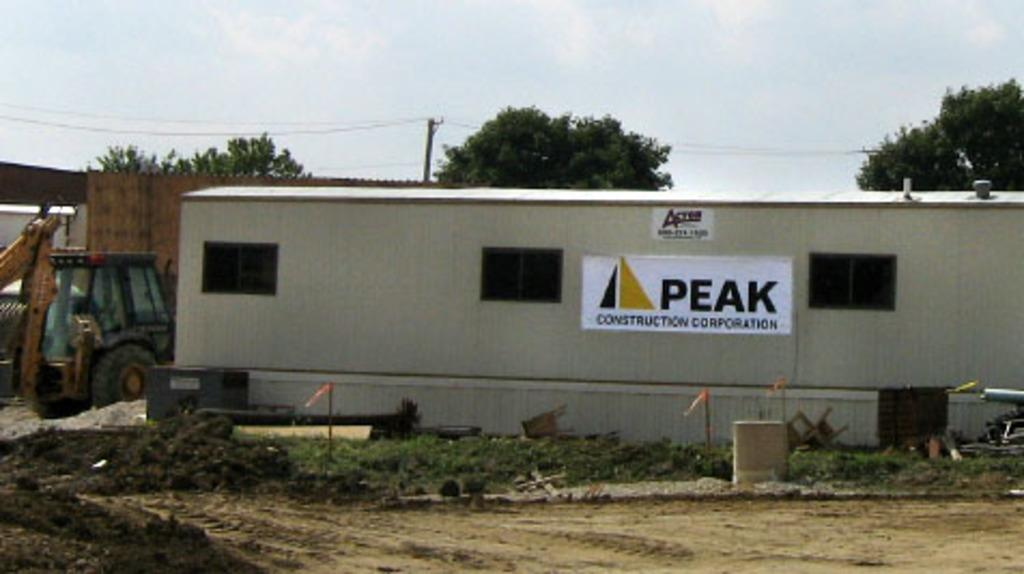What structure is located in the front portion of the image? There is a shed in the front portion of the image. What decorative items can be seen in the front portion of the image? There are banners and flags in the front portion of the image. What object is present in the front portion of the image that is typically used for storage? There is a barrel in the front portion of the image. What type of natural vegetation is visible in the front portion of the image? There is grass in the front portion of the image. What type of vehicle is present in the front portion of the image? There is a vehicle in the front portion of the image. What can be found in the background portion of the image? There is a pole and trees in the background portion of the image. What is the weather like in the background portion of the image? The sky is cloudy in the background portion of the image. What invention is being demonstrated in the image? There is no specific invention being demonstrated in the image; it features a shed, banners, flags, a barrel, grass, a vehicle, and other items in the front portion, and a pole, trees, and a cloudy sky in the background portion. What type of drink is being served in the image? There is no indication of any drinks being served in the image. 